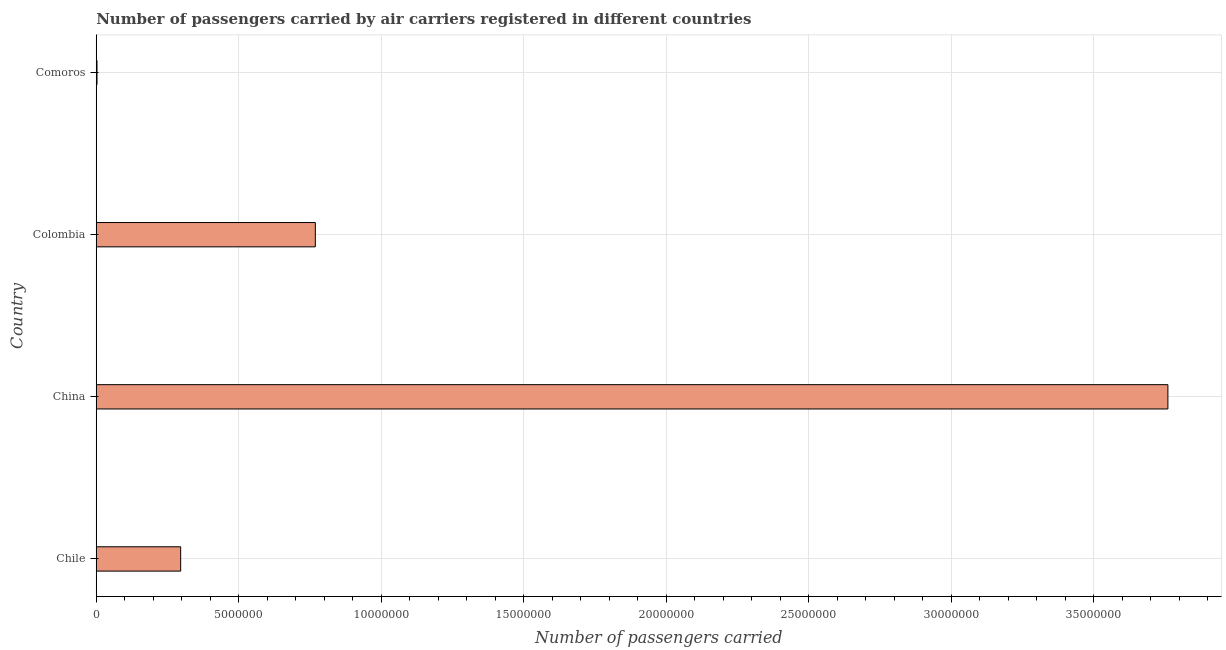What is the title of the graph?
Make the answer very short. Number of passengers carried by air carriers registered in different countries. What is the label or title of the X-axis?
Your answer should be compact. Number of passengers carried. What is the label or title of the Y-axis?
Ensure brevity in your answer.  Country. What is the number of passengers carried in Colombia?
Provide a succinct answer. 7.69e+06. Across all countries, what is the maximum number of passengers carried?
Your response must be concise. 3.76e+07. Across all countries, what is the minimum number of passengers carried?
Offer a very short reply. 2.60e+04. In which country was the number of passengers carried minimum?
Provide a short and direct response. Comoros. What is the sum of the number of passengers carried?
Keep it short and to the point. 4.83e+07. What is the difference between the number of passengers carried in Chile and Colombia?
Keep it short and to the point. -4.72e+06. What is the average number of passengers carried per country?
Your answer should be very brief. 1.21e+07. What is the median number of passengers carried?
Offer a terse response. 5.32e+06. In how many countries, is the number of passengers carried greater than 10000000 ?
Make the answer very short. 1. What is the ratio of the number of passengers carried in Colombia to that in Comoros?
Provide a succinct answer. 295.63. Is the number of passengers carried in Chile less than that in China?
Your response must be concise. Yes. What is the difference between the highest and the second highest number of passengers carried?
Provide a succinct answer. 2.99e+07. Is the sum of the number of passengers carried in Chile and Colombia greater than the maximum number of passengers carried across all countries?
Offer a very short reply. No. What is the difference between the highest and the lowest number of passengers carried?
Your response must be concise. 3.76e+07. In how many countries, is the number of passengers carried greater than the average number of passengers carried taken over all countries?
Give a very brief answer. 1. What is the difference between two consecutive major ticks on the X-axis?
Your response must be concise. 5.00e+06. What is the Number of passengers carried of Chile?
Offer a very short reply. 2.96e+06. What is the Number of passengers carried in China?
Make the answer very short. 3.76e+07. What is the Number of passengers carried of Colombia?
Provide a short and direct response. 7.69e+06. What is the Number of passengers carried in Comoros?
Ensure brevity in your answer.  2.60e+04. What is the difference between the Number of passengers carried in Chile and China?
Your answer should be compact. -3.46e+07. What is the difference between the Number of passengers carried in Chile and Colombia?
Offer a very short reply. -4.72e+06. What is the difference between the Number of passengers carried in Chile and Comoros?
Your answer should be compact. 2.94e+06. What is the difference between the Number of passengers carried in China and Colombia?
Keep it short and to the point. 2.99e+07. What is the difference between the Number of passengers carried in China and Comoros?
Offer a very short reply. 3.76e+07. What is the difference between the Number of passengers carried in Colombia and Comoros?
Ensure brevity in your answer.  7.66e+06. What is the ratio of the Number of passengers carried in Chile to that in China?
Ensure brevity in your answer.  0.08. What is the ratio of the Number of passengers carried in Chile to that in Colombia?
Keep it short and to the point. 0.39. What is the ratio of the Number of passengers carried in Chile to that in Comoros?
Make the answer very short. 113.91. What is the ratio of the Number of passengers carried in China to that in Colombia?
Give a very brief answer. 4.89. What is the ratio of the Number of passengers carried in China to that in Comoros?
Keep it short and to the point. 1446.19. What is the ratio of the Number of passengers carried in Colombia to that in Comoros?
Ensure brevity in your answer.  295.63. 